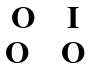Convert formula to latex. <formula><loc_0><loc_0><loc_500><loc_500>\begin{matrix} { \mathbf O \quad \mathbf I } \\ { \mathbf O \quad \mathbf O } \end{matrix}</formula> 